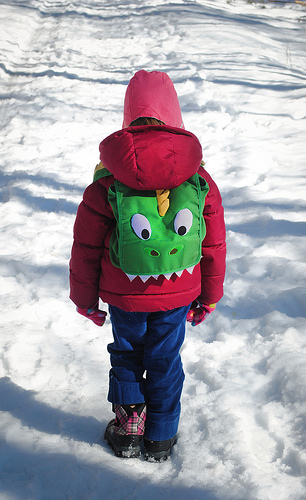<image>
Is the boy in the snow? Yes. The boy is contained within or inside the snow, showing a containment relationship. 